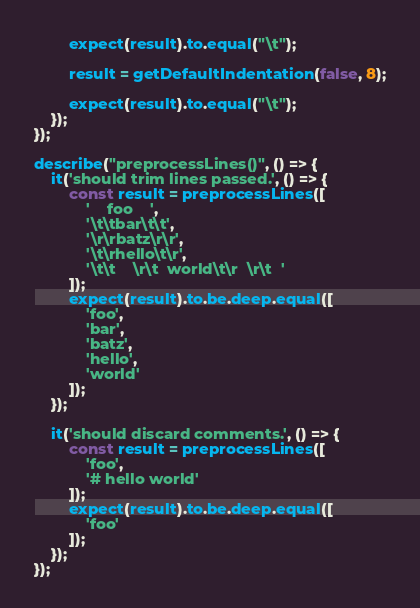Convert code to text. <code><loc_0><loc_0><loc_500><loc_500><_TypeScript_>        expect(result).to.equal("\t");

        result = getDefaultIndentation(false, 8);

        expect(result).to.equal("\t");
    });
});

describe("preprocessLines()", () => {
    it('should trim lines passed.', () => {
        const result = preprocessLines([
            '    foo    ',
            '\t\tbar\t\t',
            '\r\rbatz\r\r',
            '\t\rhello\t\r',
            '\t\t    \r\t  world\t\r  \r\t  '
        ]);
        expect(result).to.be.deep.equal([
            'foo',
            'bar',
            'batz',
            'hello',
            'world'
        ]);
    });

    it('should discard comments.', () => {
        const result = preprocessLines([
            'foo',
            '# hello world'
        ]);
        expect(result).to.be.deep.equal([
            'foo'
        ]);
    });
});
</code> 